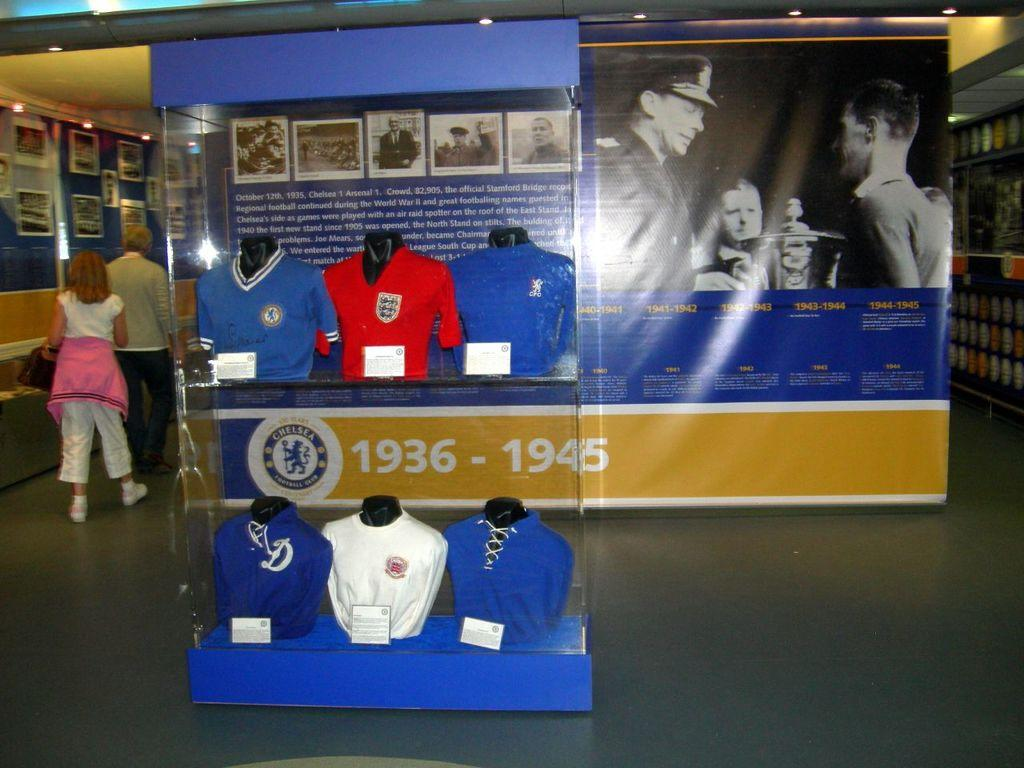Provide a one-sentence caption for the provided image. A sports display spans the years 1936 to 1945. 